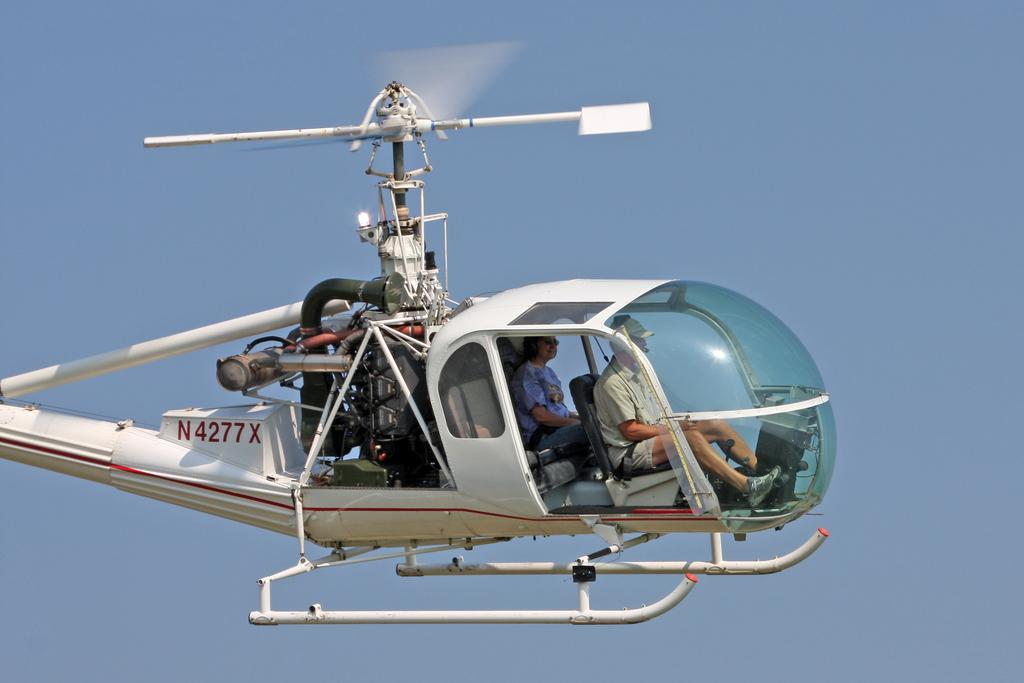<image>
Provide a brief description of the given image. The N4277X helicopter transports a person while midair. 